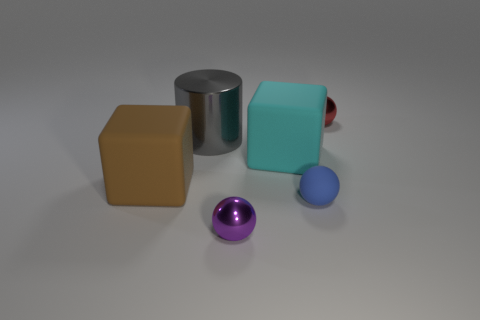What is the shape of the big thing in front of the big matte object that is right of the small purple sphere?
Make the answer very short. Cube. What shape is the cyan matte object that is the same size as the brown matte cube?
Your response must be concise. Cube. Are there any rubber things that have the same color as the cylinder?
Provide a short and direct response. No. Are there the same number of tiny red objects in front of the blue matte thing and small rubber objects behind the big cyan rubber block?
Ensure brevity in your answer.  Yes. Is the shape of the red object the same as the big cyan thing that is in front of the gray shiny cylinder?
Offer a very short reply. No. How many other objects are the same material as the gray object?
Your answer should be compact. 2. There is a large cyan object; are there any balls to the right of it?
Keep it short and to the point. Yes. There is a brown thing; does it have the same size as the shiny sphere behind the gray metal cylinder?
Offer a very short reply. No. What color is the tiny metallic ball in front of the metal sphere that is right of the purple shiny ball?
Offer a very short reply. Purple. Do the gray cylinder and the brown rubber block have the same size?
Keep it short and to the point. Yes. 